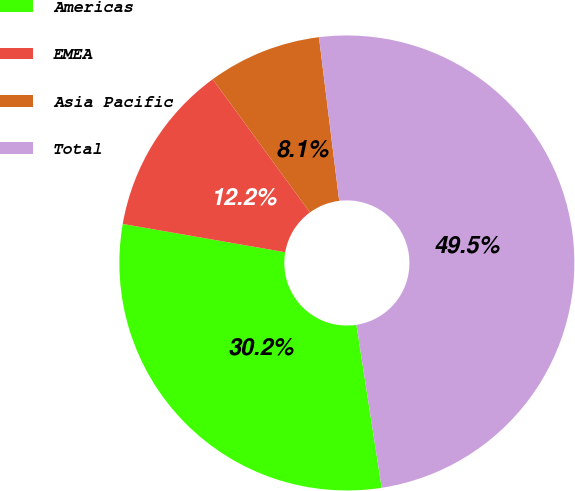<chart> <loc_0><loc_0><loc_500><loc_500><pie_chart><fcel>Americas<fcel>EMEA<fcel>Asia Pacific<fcel>Total<nl><fcel>30.19%<fcel>12.22%<fcel>8.08%<fcel>49.51%<nl></chart> 